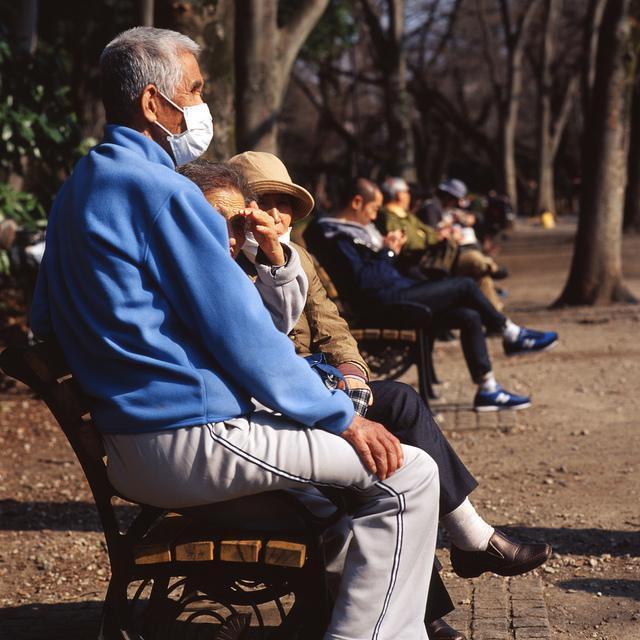How many benches can you see?
Give a very brief answer. 2. How many people are there?
Give a very brief answer. 6. How many chairs at the table?
Give a very brief answer. 0. 